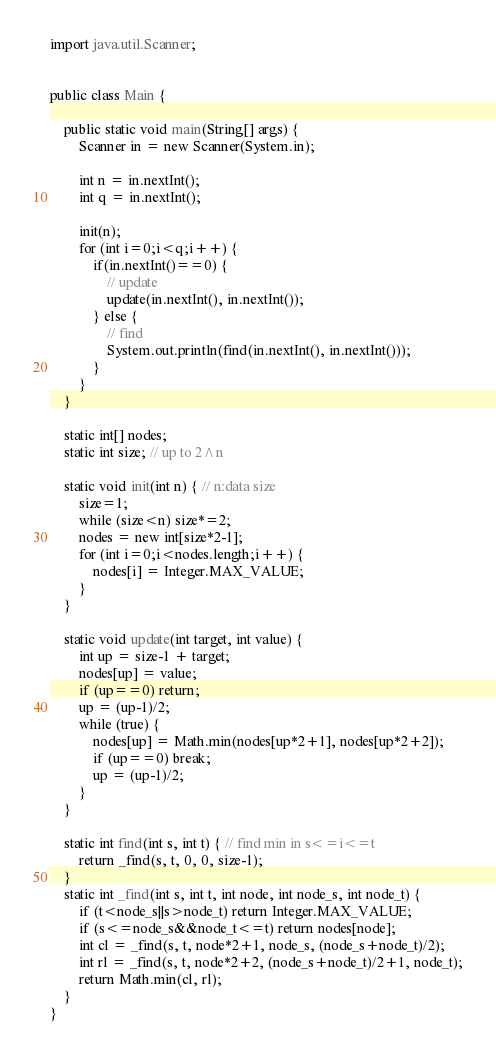<code> <loc_0><loc_0><loc_500><loc_500><_Java_>import java.util.Scanner;


public class Main {

	public static void main(String[] args) {
		Scanner in = new Scanner(System.in);

		int n = in.nextInt();
		int q = in.nextInt();
		
		init(n);
		for (int i=0;i<q;i++) {
			if(in.nextInt()==0) {
				// update
				update(in.nextInt(), in.nextInt());
			} else {
				// find
				System.out.println(find(in.nextInt(), in.nextInt()));
			}
		}
	}
	
	static int[] nodes;
	static int size; // up to 2^n

	static void init(int n) { // n:data size
		size=1;
		while (size<n) size*=2;
		nodes = new int[size*2-1];
		for (int i=0;i<nodes.length;i++) {
			nodes[i] = Integer.MAX_VALUE;
		}
	}
	
	static void update(int target, int value) {
		int up = size-1 + target;
		nodes[up] = value;
		if (up==0) return;
		up = (up-1)/2;
		while (true) {
			nodes[up] = Math.min(nodes[up*2+1], nodes[up*2+2]);
			if (up==0) break;
			up = (up-1)/2;
		}
	}
	
	static int find(int s, int t) { // find min in s<=i<=t
		return _find(s, t, 0, 0, size-1);
	}
	static int _find(int s, int t, int node, int node_s, int node_t) {
		if (t<node_s||s>node_t) return Integer.MAX_VALUE;
		if (s<=node_s&&node_t<=t) return nodes[node];
		int cl = _find(s, t, node*2+1, node_s, (node_s+node_t)/2);
		int rl = _find(s, t, node*2+2, (node_s+node_t)/2+1, node_t);
		return Math.min(cl, rl);
	}
}</code> 